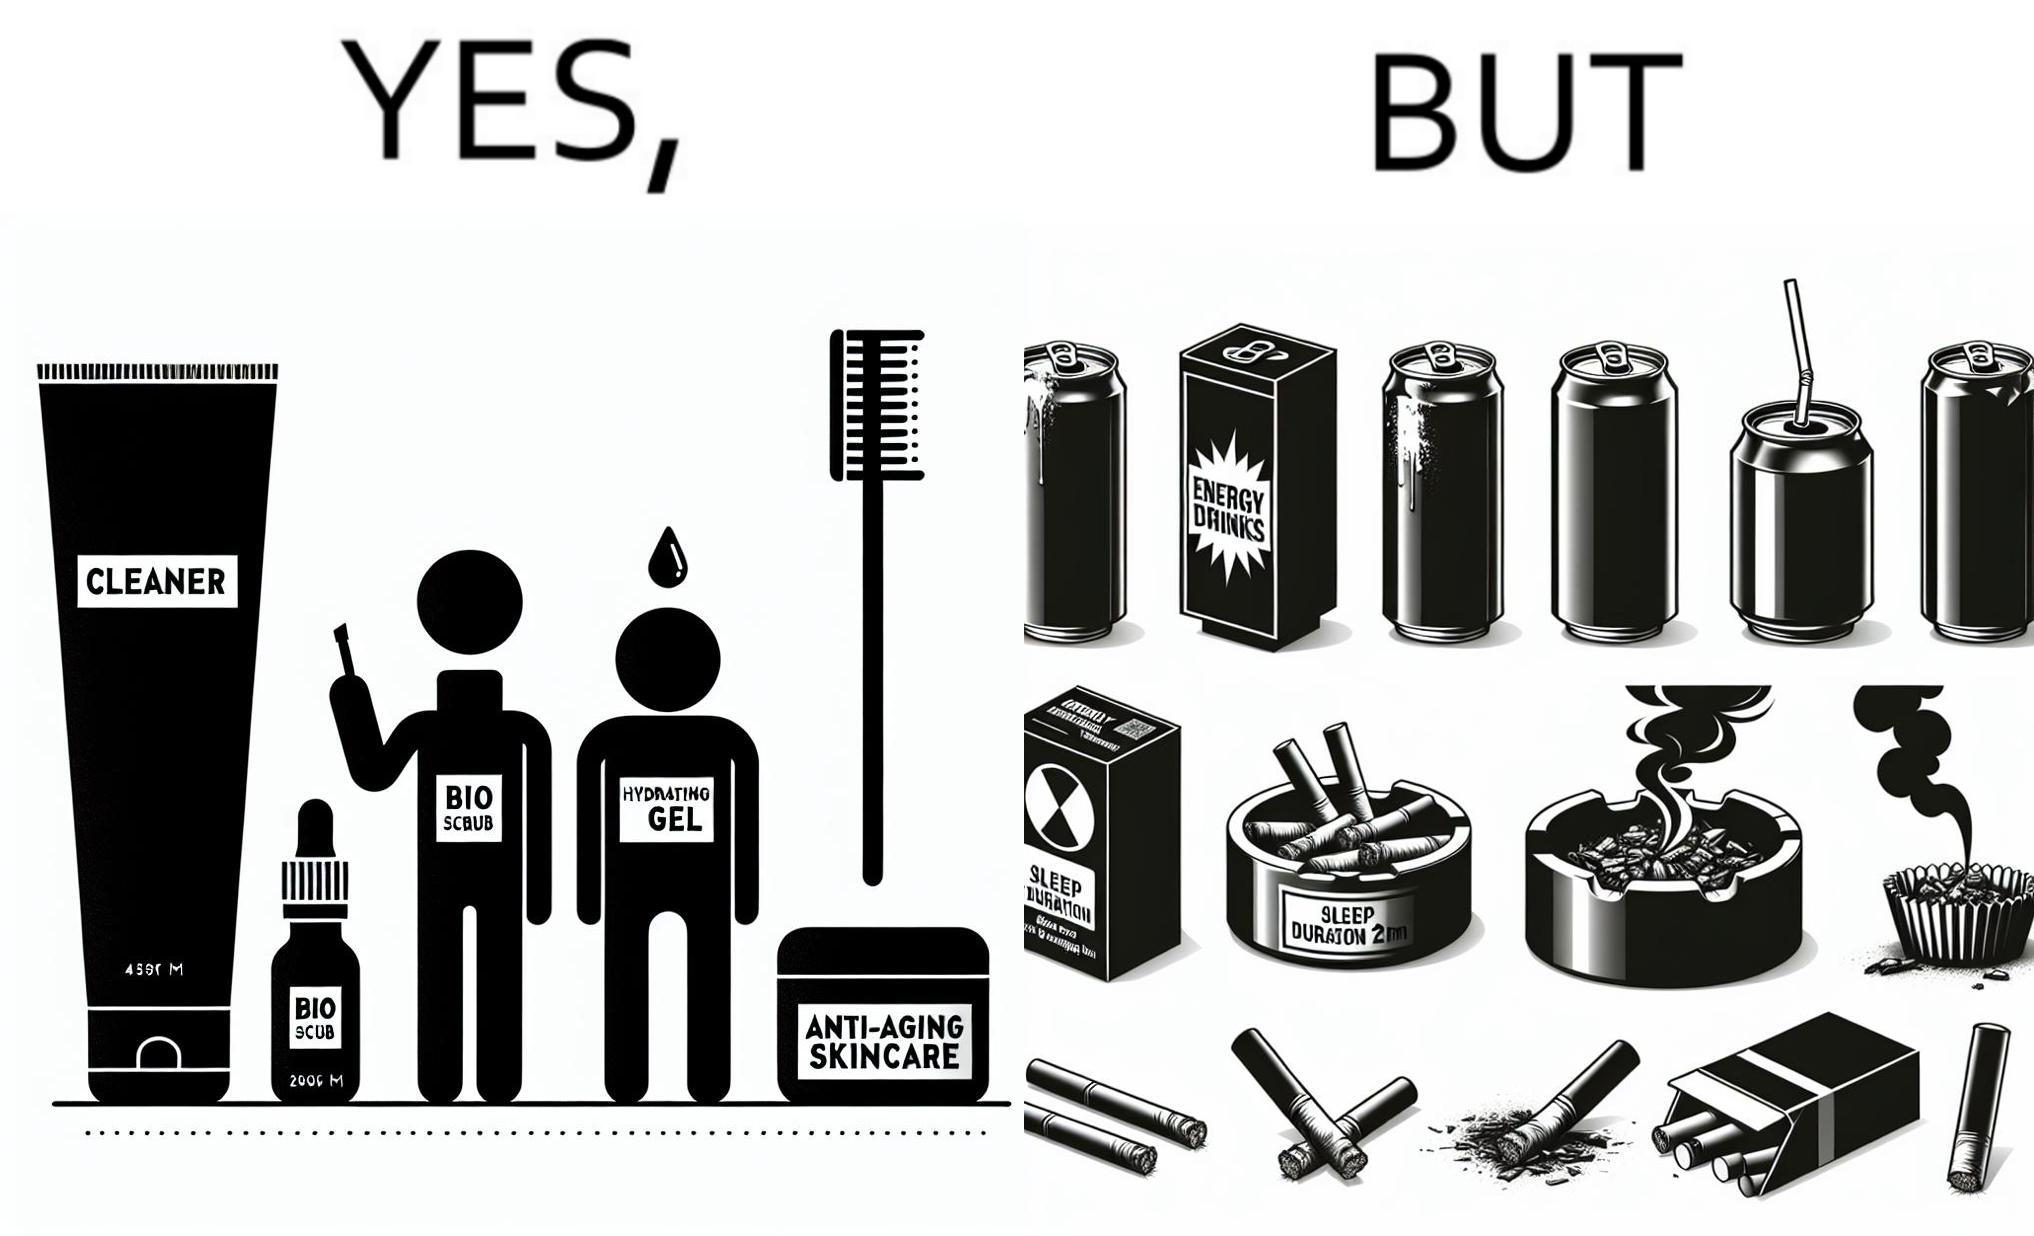Explain the humor or irony in this image. This image is ironic as on the one hand, the presumed person is into skincare and wants to do the best for their skin, which is good, but on the other hand, they are involved in unhealthy habits that will damage their skin like smoking, caffeine and inadequate sleep. 